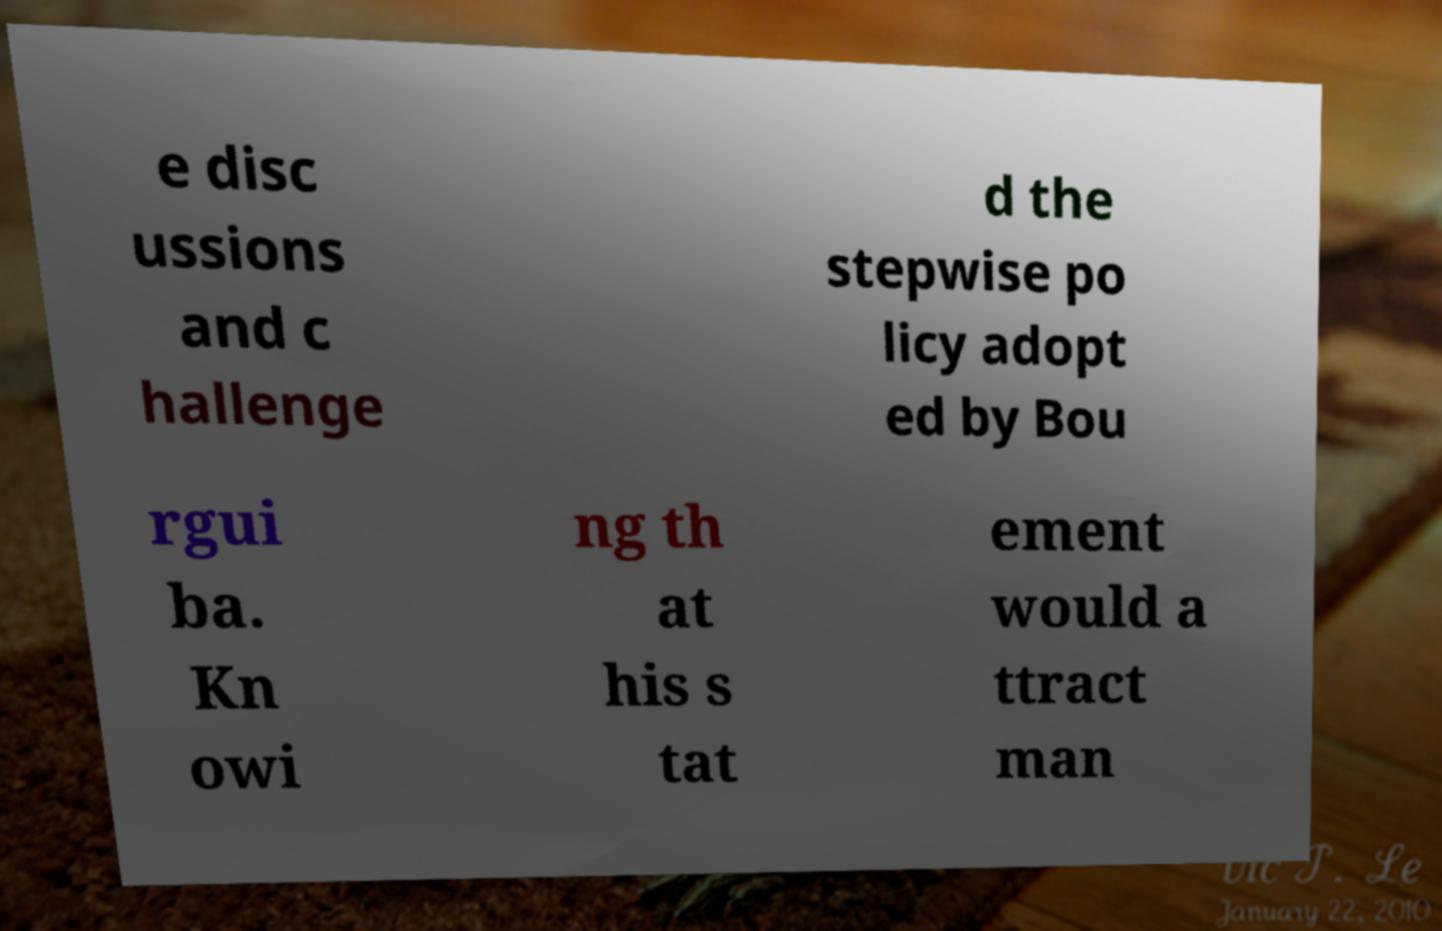Could you assist in decoding the text presented in this image and type it out clearly? e disc ussions and c hallenge d the stepwise po licy adopt ed by Bou rgui ba. Kn owi ng th at his s tat ement would a ttract man 